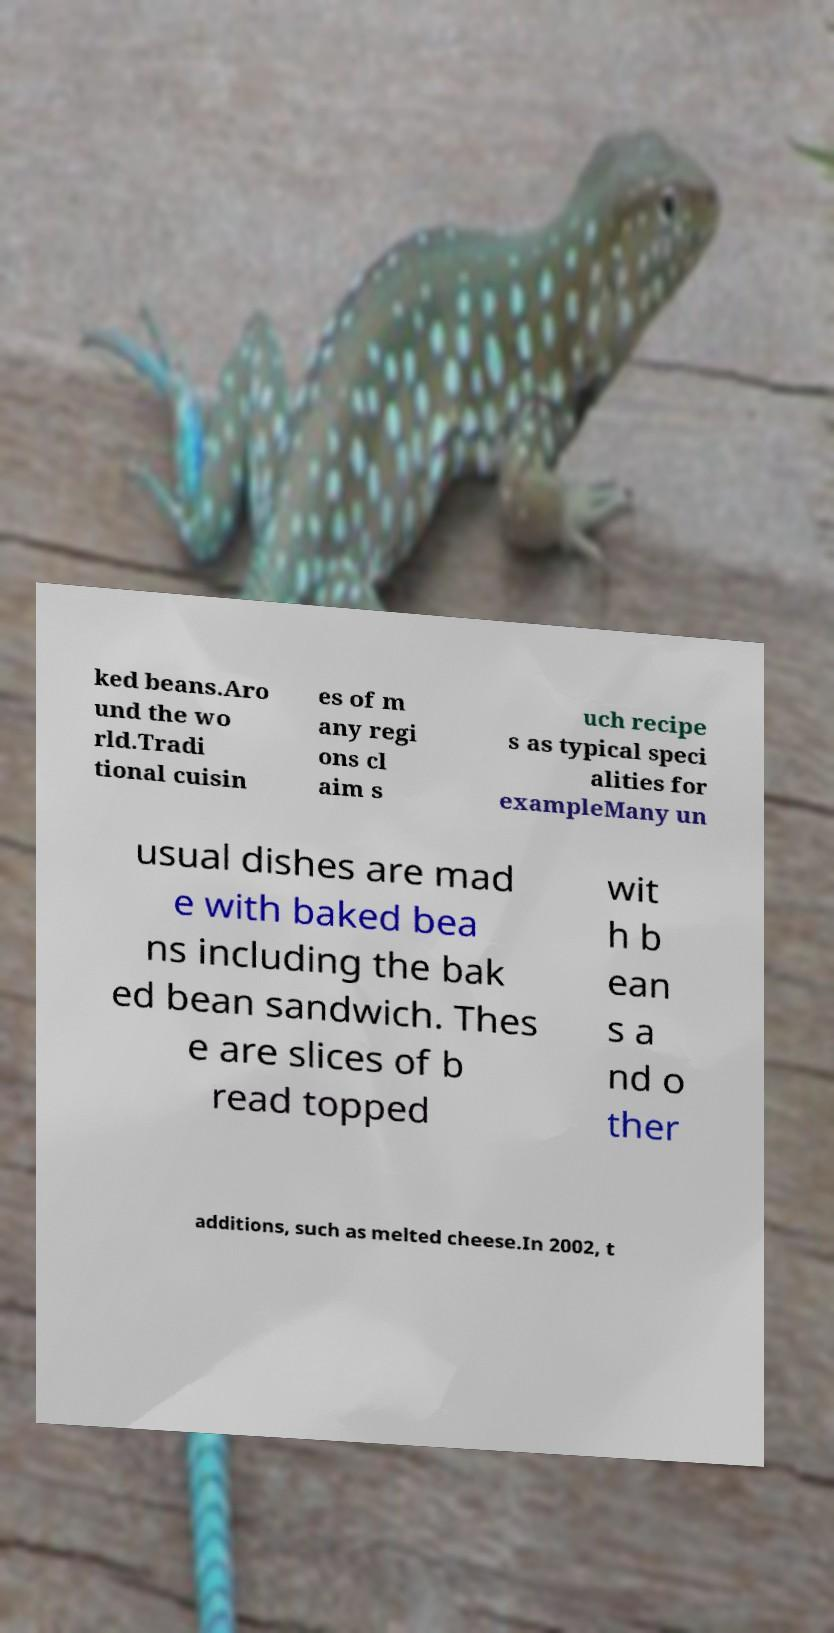For documentation purposes, I need the text within this image transcribed. Could you provide that? ked beans.Aro und the wo rld.Tradi tional cuisin es of m any regi ons cl aim s uch recipe s as typical speci alities for exampleMany un usual dishes are mad e with baked bea ns including the bak ed bean sandwich. Thes e are slices of b read topped wit h b ean s a nd o ther additions, such as melted cheese.In 2002, t 